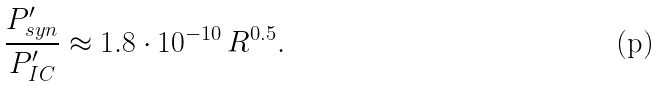<formula> <loc_0><loc_0><loc_500><loc_500>\frac { P ^ { \prime } _ { s y n } } { P ^ { \prime } _ { I C } } \approx 1 . 8 \cdot 1 0 ^ { - 1 0 } \, R ^ { 0 . 5 } .</formula> 